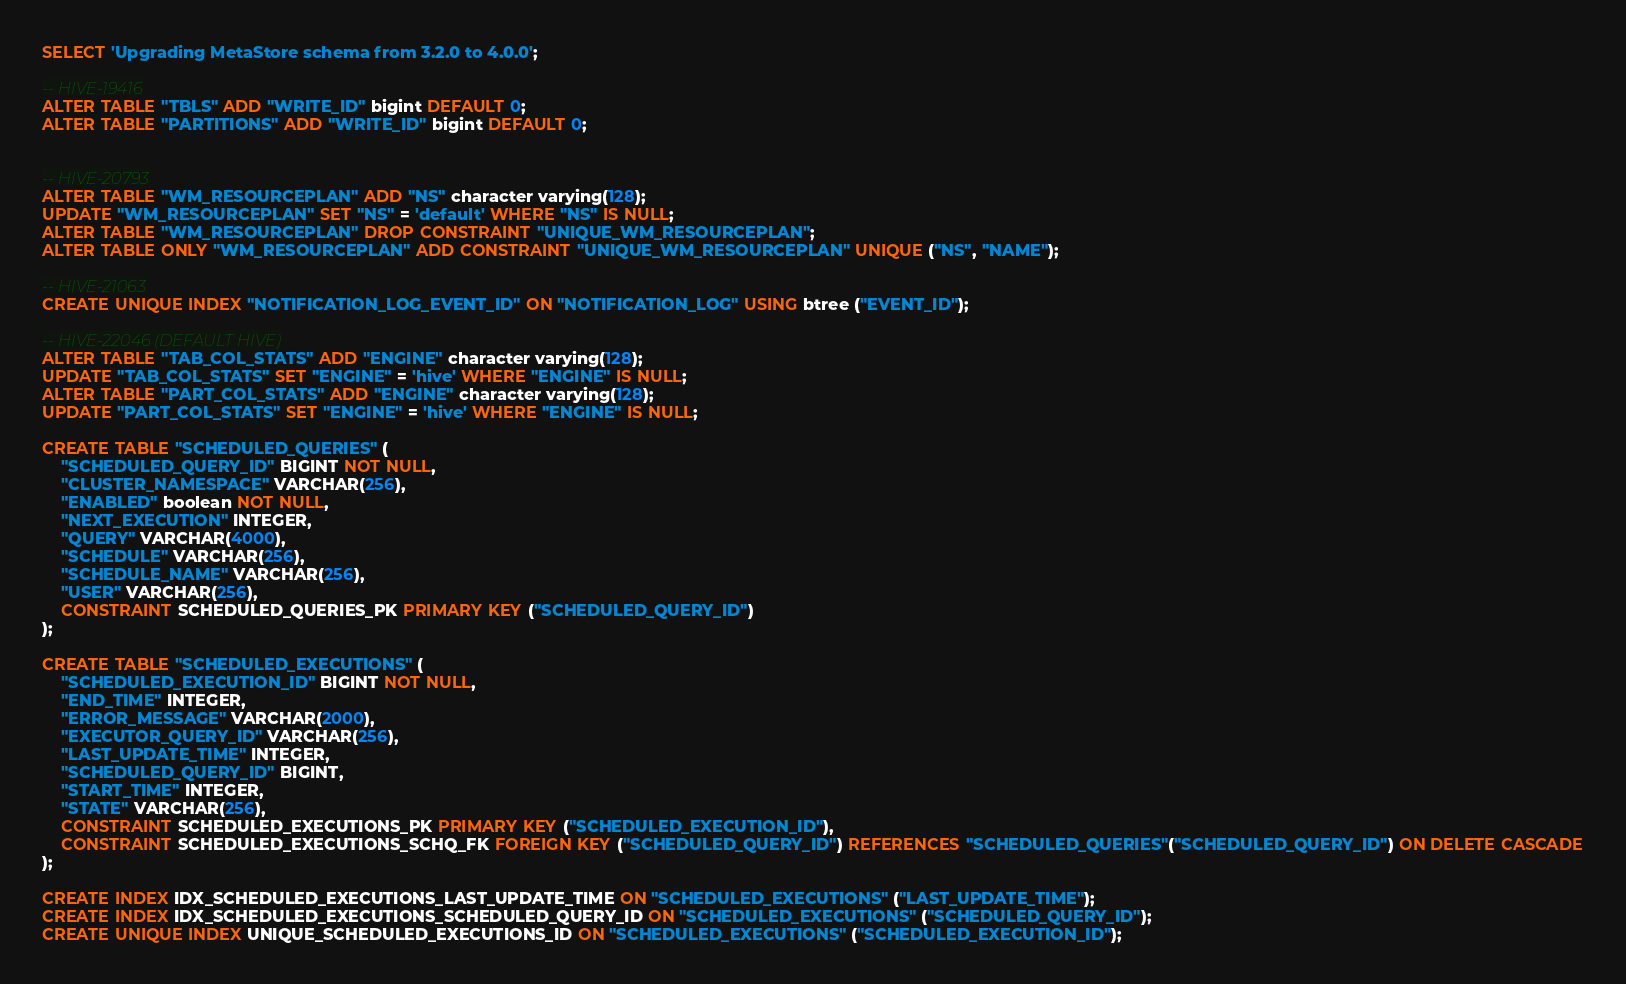Convert code to text. <code><loc_0><loc_0><loc_500><loc_500><_SQL_>SELECT 'Upgrading MetaStore schema from 3.2.0 to 4.0.0';

-- HIVE-19416
ALTER TABLE "TBLS" ADD "WRITE_ID" bigint DEFAULT 0;
ALTER TABLE "PARTITIONS" ADD "WRITE_ID" bigint DEFAULT 0;


-- HIVE-20793
ALTER TABLE "WM_RESOURCEPLAN" ADD "NS" character varying(128);
UPDATE "WM_RESOURCEPLAN" SET "NS" = 'default' WHERE "NS" IS NULL;
ALTER TABLE "WM_RESOURCEPLAN" DROP CONSTRAINT "UNIQUE_WM_RESOURCEPLAN";
ALTER TABLE ONLY "WM_RESOURCEPLAN" ADD CONSTRAINT "UNIQUE_WM_RESOURCEPLAN" UNIQUE ("NS", "NAME");

-- HIVE-21063
CREATE UNIQUE INDEX "NOTIFICATION_LOG_EVENT_ID" ON "NOTIFICATION_LOG" USING btree ("EVENT_ID");

-- HIVE-22046 (DEFAULT HIVE)
ALTER TABLE "TAB_COL_STATS" ADD "ENGINE" character varying(128);
UPDATE "TAB_COL_STATS" SET "ENGINE" = 'hive' WHERE "ENGINE" IS NULL;
ALTER TABLE "PART_COL_STATS" ADD "ENGINE" character varying(128);
UPDATE "PART_COL_STATS" SET "ENGINE" = 'hive' WHERE "ENGINE" IS NULL;

CREATE TABLE "SCHEDULED_QUERIES" (
	"SCHEDULED_QUERY_ID" BIGINT NOT NULL,
	"CLUSTER_NAMESPACE" VARCHAR(256),
	"ENABLED" boolean NOT NULL,
	"NEXT_EXECUTION" INTEGER,
	"QUERY" VARCHAR(4000),
	"SCHEDULE" VARCHAR(256),
	"SCHEDULE_NAME" VARCHAR(256),
	"USER" VARCHAR(256),
	CONSTRAINT SCHEDULED_QUERIES_PK PRIMARY KEY ("SCHEDULED_QUERY_ID")
);

CREATE TABLE "SCHEDULED_EXECUTIONS" (
	"SCHEDULED_EXECUTION_ID" BIGINT NOT NULL,
	"END_TIME" INTEGER,
	"ERROR_MESSAGE" VARCHAR(2000),
	"EXECUTOR_QUERY_ID" VARCHAR(256),
	"LAST_UPDATE_TIME" INTEGER,
	"SCHEDULED_QUERY_ID" BIGINT,
	"START_TIME" INTEGER,
	"STATE" VARCHAR(256),
	CONSTRAINT SCHEDULED_EXECUTIONS_PK PRIMARY KEY ("SCHEDULED_EXECUTION_ID"),
	CONSTRAINT SCHEDULED_EXECUTIONS_SCHQ_FK FOREIGN KEY ("SCHEDULED_QUERY_ID") REFERENCES "SCHEDULED_QUERIES"("SCHEDULED_QUERY_ID") ON DELETE CASCADE
);

CREATE INDEX IDX_SCHEDULED_EXECUTIONS_LAST_UPDATE_TIME ON "SCHEDULED_EXECUTIONS" ("LAST_UPDATE_TIME");
CREATE INDEX IDX_SCHEDULED_EXECUTIONS_SCHEDULED_QUERY_ID ON "SCHEDULED_EXECUTIONS" ("SCHEDULED_QUERY_ID");
CREATE UNIQUE INDEX UNIQUE_SCHEDULED_EXECUTIONS_ID ON "SCHEDULED_EXECUTIONS" ("SCHEDULED_EXECUTION_ID");
</code> 